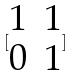Convert formula to latex. <formula><loc_0><loc_0><loc_500><loc_500>[ \begin{matrix} 1 & 1 \\ 0 & 1 \end{matrix} ]</formula> 